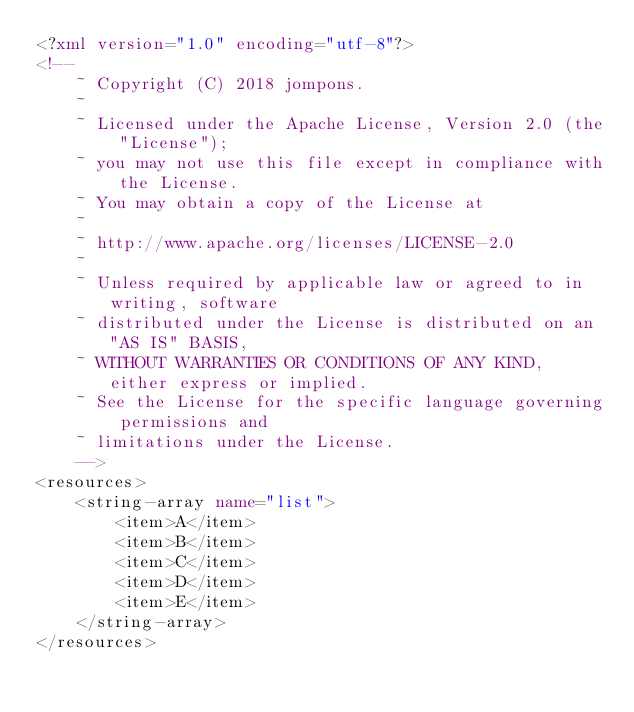<code> <loc_0><loc_0><loc_500><loc_500><_XML_><?xml version="1.0" encoding="utf-8"?>
<!--
    ~ Copyright (C) 2018 jompons.
    ~
    ~ Licensed under the Apache License, Version 2.0 (the "License");
    ~ you may not use this file except in compliance with the License.
    ~ You may obtain a copy of the License at
    ~
    ~ http://www.apache.org/licenses/LICENSE-2.0
    ~
    ~ Unless required by applicable law or agreed to in writing, software
    ~ distributed under the License is distributed on an "AS IS" BASIS,
    ~ WITHOUT WARRANTIES OR CONDITIONS OF ANY KIND, either express or implied.
    ~ See the License for the specific language governing permissions and
    ~ limitations under the License.
    -->
<resources>
    <string-array name="list">
        <item>A</item>
        <item>B</item>
        <item>C</item>
        <item>D</item>
        <item>E</item>
    </string-array>
</resources></code> 